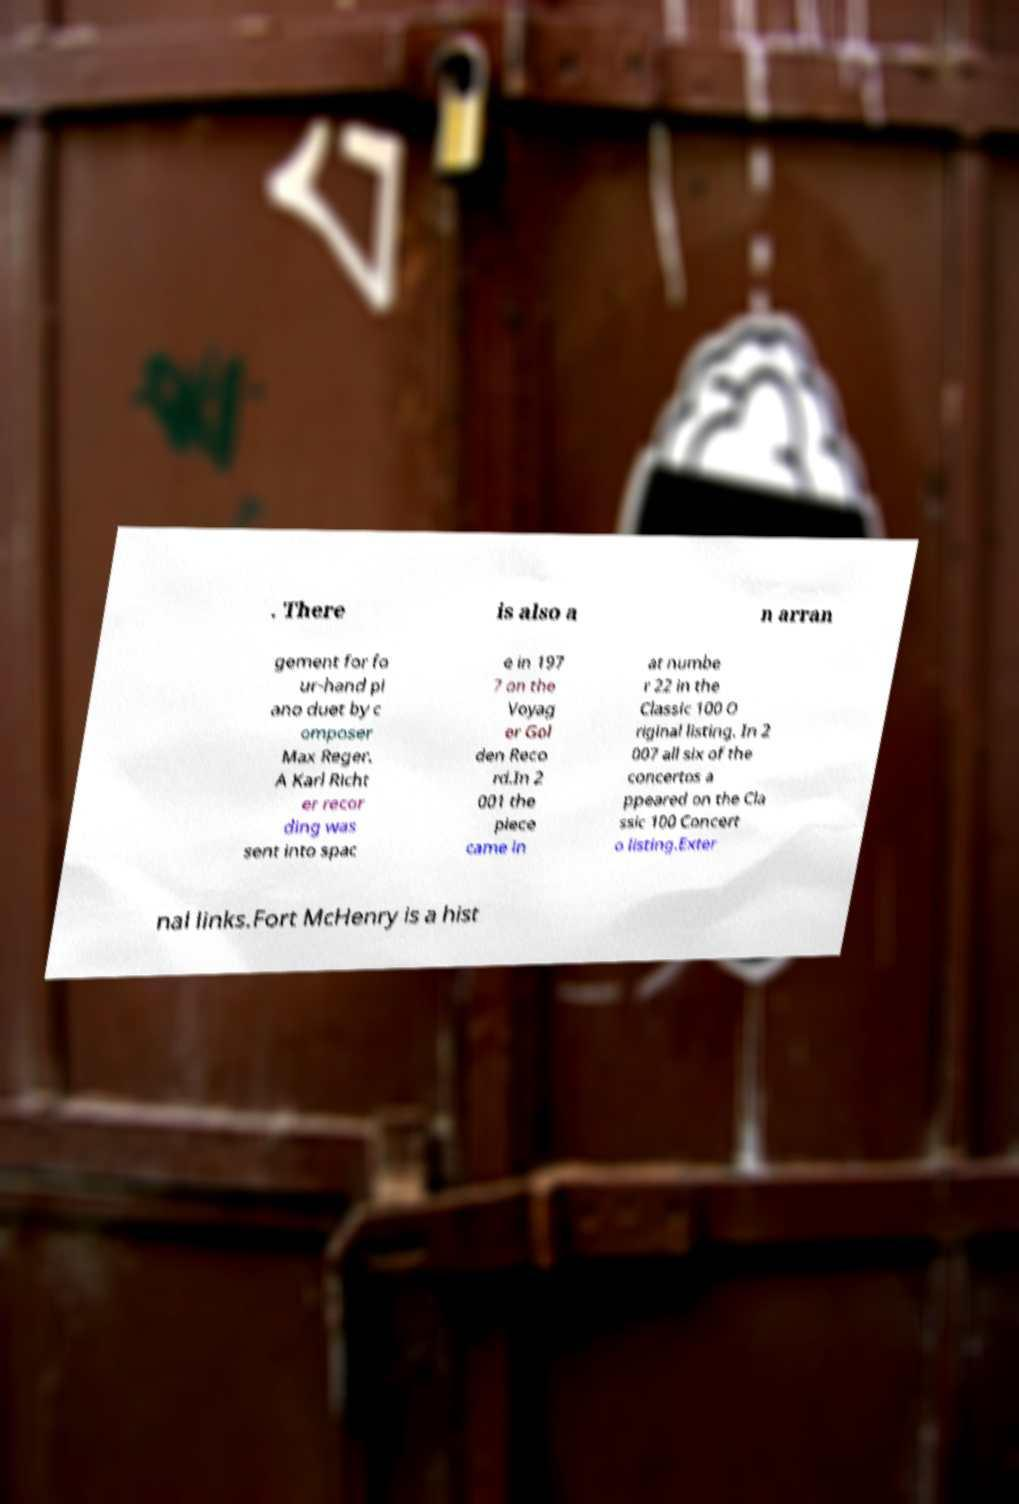Can you accurately transcribe the text from the provided image for me? . There is also a n arran gement for fo ur-hand pi ano duet by c omposer Max Reger. A Karl Richt er recor ding was sent into spac e in 197 7 on the Voyag er Gol den Reco rd.In 2 001 the piece came in at numbe r 22 in the Classic 100 O riginal listing. In 2 007 all six of the concertos a ppeared on the Cla ssic 100 Concert o listing.Exter nal links.Fort McHenry is a hist 